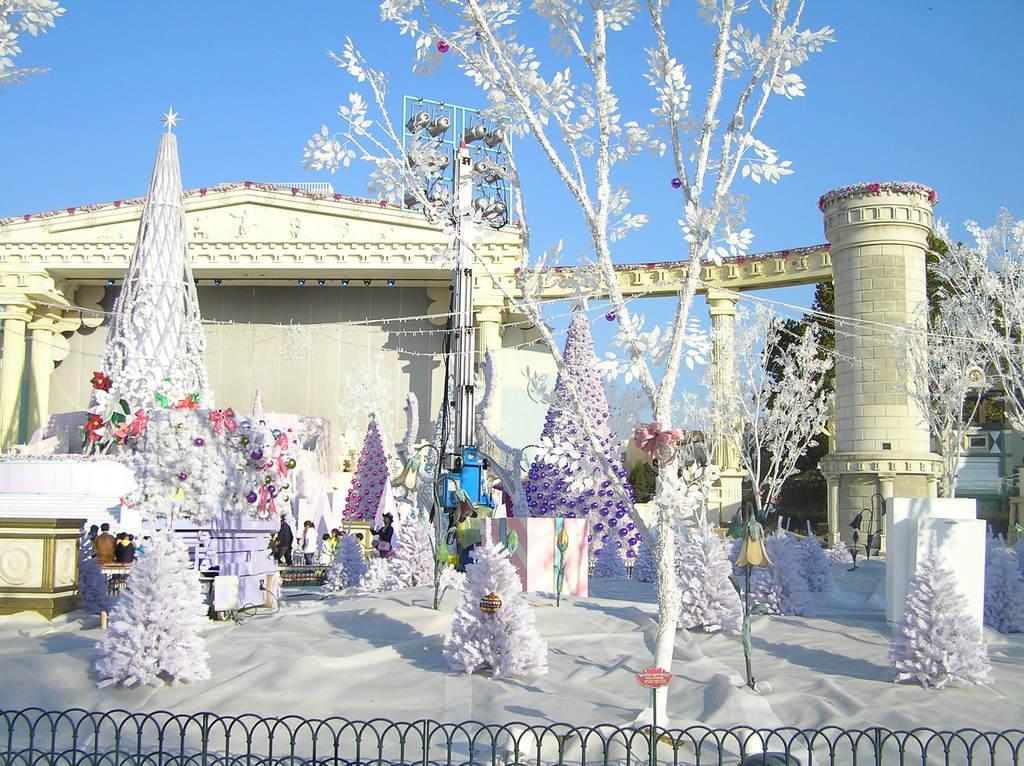In one or two sentences, can you explain what this image depicts? In this image there are some christmas trees, and the trees are decorated and also there are buildings, trees, poles, pillars. In the center there is pole and some lights, at the bottom of the image there is a railing and on the left side of the image there are some people and some other objects. At the bottom there is walkway, and at the top there is sky. 